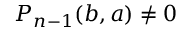<formula> <loc_0><loc_0><loc_500><loc_500>P _ { n - 1 } ( b , a ) \neq 0</formula> 